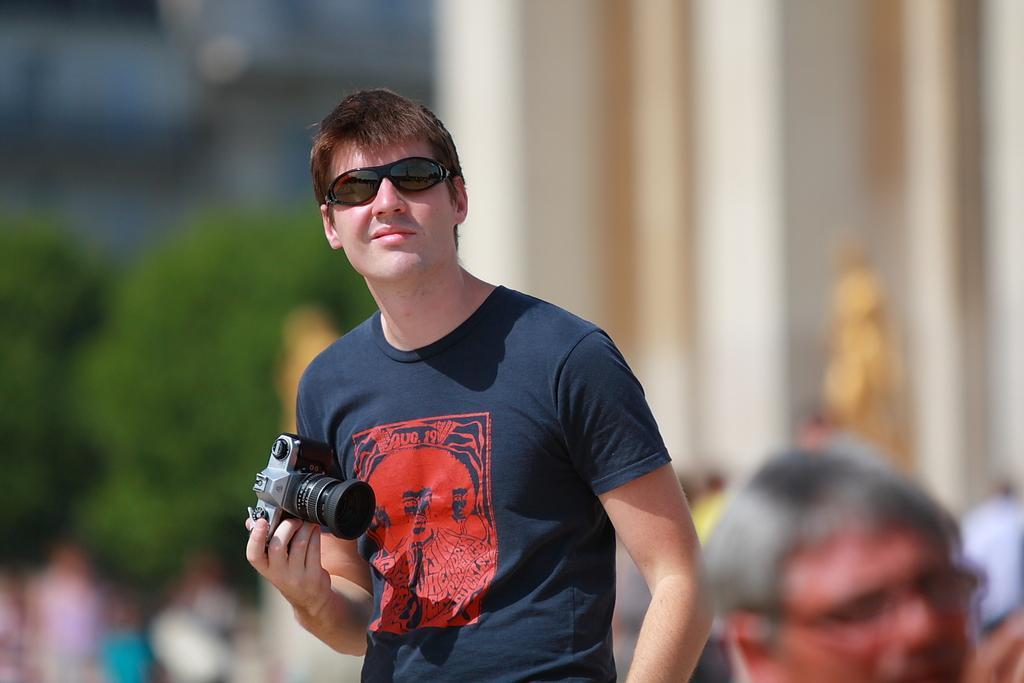In one or two sentences, can you explain what this image depicts? In the image we can see there is a man who is standing and wearing glasses and holding a camera. At the back the image is blur. 